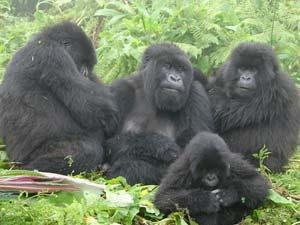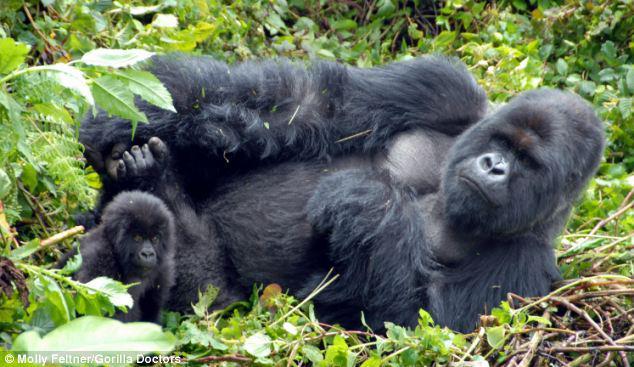The first image is the image on the left, the second image is the image on the right. Given the left and right images, does the statement "In each image, the gorilla closest to the camera is on all fours." hold true? Answer yes or no. No. The first image is the image on the left, the second image is the image on the right. Given the left and right images, does the statement "The left image contains exactly four gorillas." hold true? Answer yes or no. Yes. 